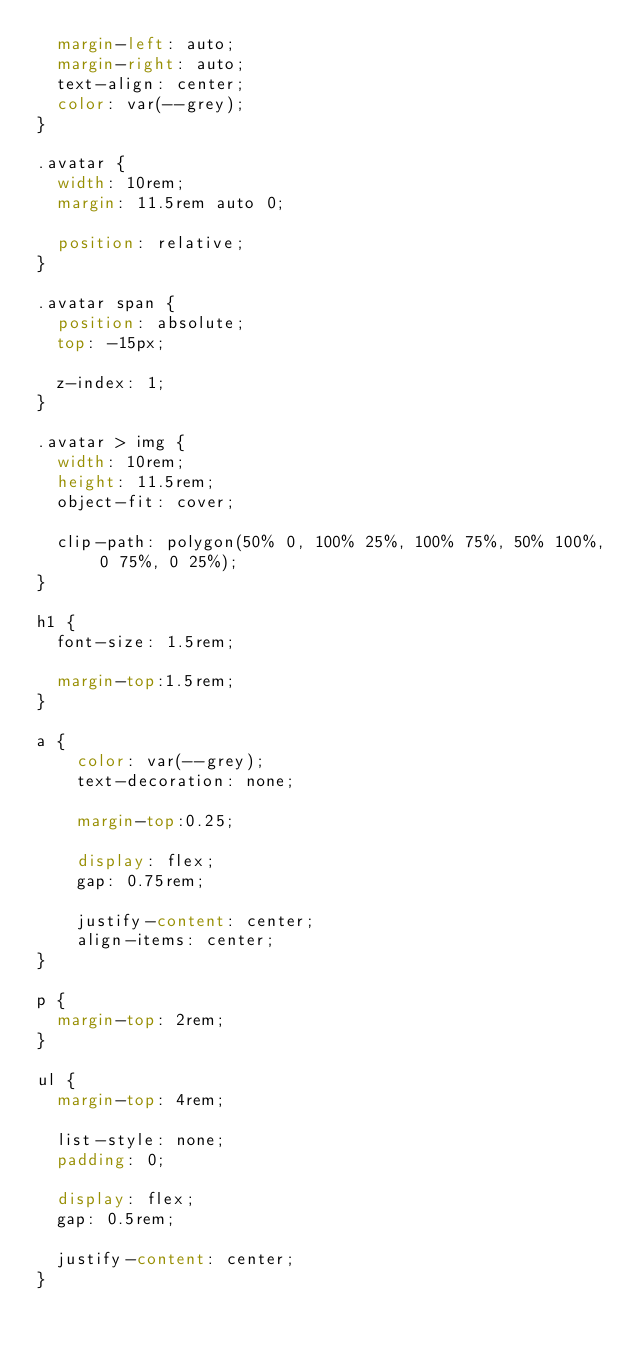<code> <loc_0><loc_0><loc_500><loc_500><_CSS_>  margin-left: auto;
  margin-right: auto;
  text-align: center;
  color: var(--grey);
}

.avatar {
  width: 10rem;
  margin: 11.5rem auto 0;

  position: relative;
}

.avatar span {
  position: absolute;
  top: -15px;

  z-index: 1;
}

.avatar > img {
  width: 10rem;
  height: 11.5rem;
  object-fit: cover;

  clip-path: polygon(50% 0, 100% 25%, 100% 75%, 50% 100%, 0 75%, 0 25%);
}

h1 {
  font-size: 1.5rem;

  margin-top:1.5rem;
}

a {
    color: var(--grey);
    text-decoration: none;

    margin-top:0.25;

    display: flex;
    gap: 0.75rem;

    justify-content: center;
    align-items: center;
}

p {
  margin-top: 2rem;
}

ul {
  margin-top: 4rem;

  list-style: none;
  padding: 0;

  display: flex;
  gap: 0.5rem;

  justify-content: center;
}
</code> 